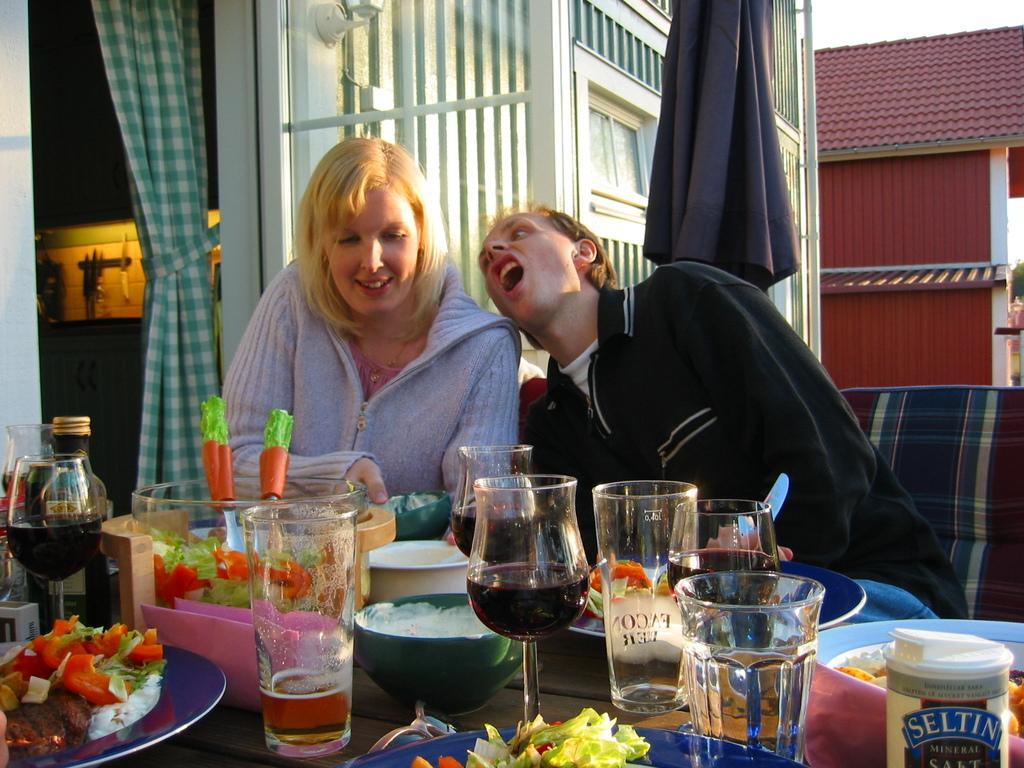In one or two sentences, can you explain what this image depicts? In this picture I can see a table in front, on which there are number of glasses, cups and different types of food items and behind the table I can see 2 women who are sitting and in the background I can see the clothes and I can see a building. On the left side of this image I see that it is a bit dark and I see the light. 